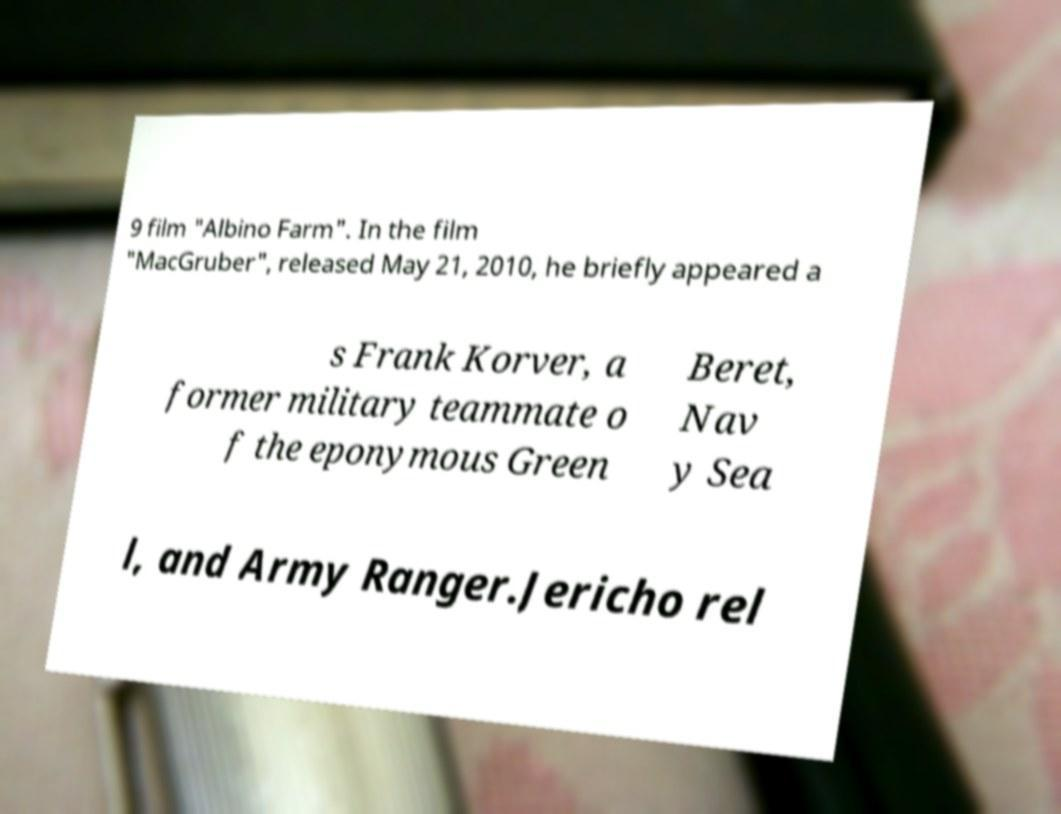For documentation purposes, I need the text within this image transcribed. Could you provide that? 9 film "Albino Farm". In the film "MacGruber", released May 21, 2010, he briefly appeared a s Frank Korver, a former military teammate o f the eponymous Green Beret, Nav y Sea l, and Army Ranger.Jericho rel 